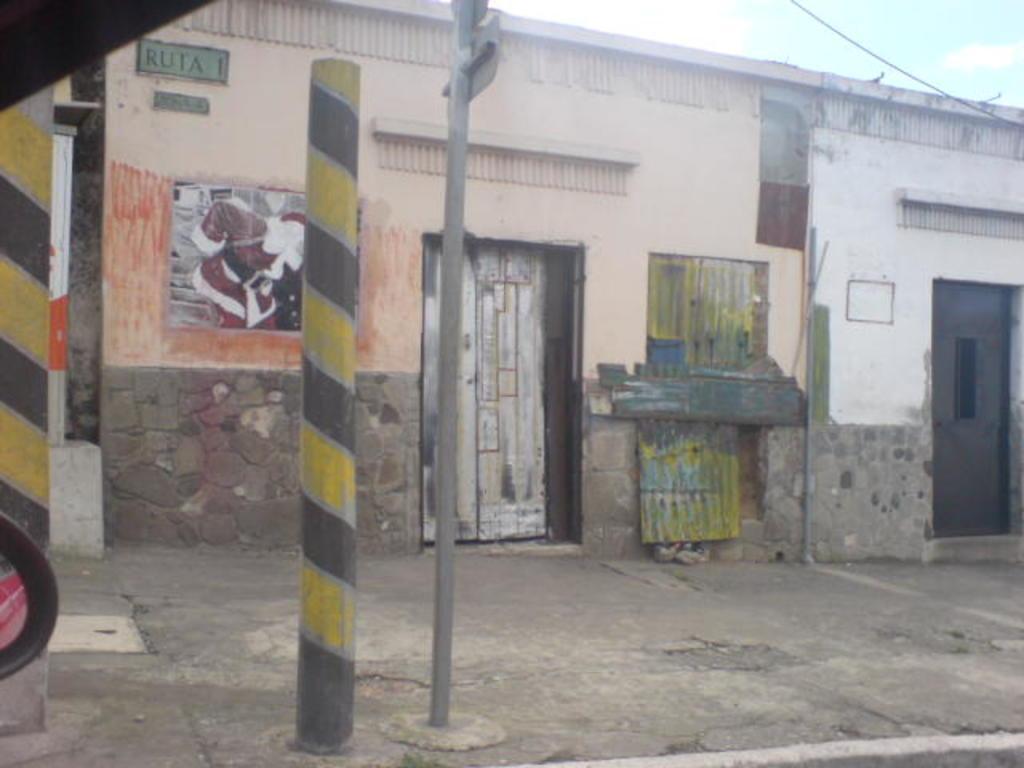How would you summarize this image in a sentence or two? At the left corner of the image there is a pole with yellow and black painting on it. In the background there is a house with walls, windows, paintings and doors. In front of the building there are poles. At the top right corner of the image there is a sky. 